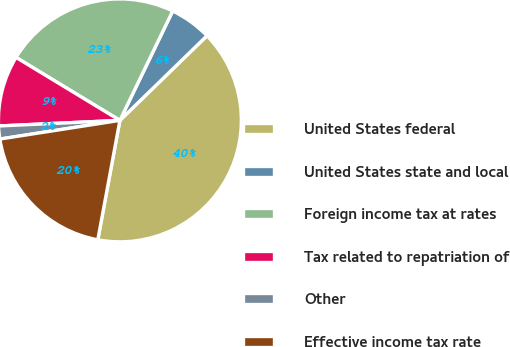Convert chart to OTSL. <chart><loc_0><loc_0><loc_500><loc_500><pie_chart><fcel>United States federal<fcel>United States state and local<fcel>Foreign income tax at rates<fcel>Tax related to repatriation of<fcel>Other<fcel>Effective income tax rate<nl><fcel>40.18%<fcel>5.57%<fcel>23.48%<fcel>9.41%<fcel>1.72%<fcel>19.63%<nl></chart> 